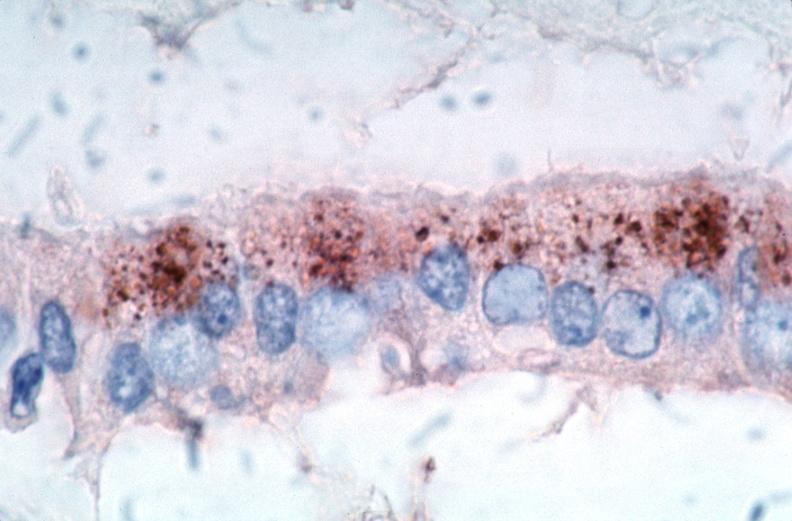s vasculature present?
Answer the question using a single word or phrase. Yes 